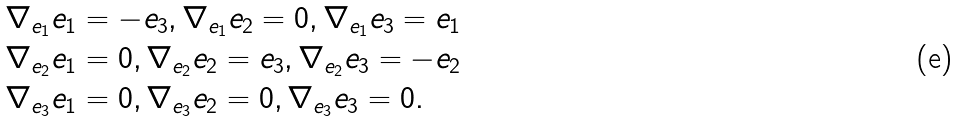<formula> <loc_0><loc_0><loc_500><loc_500>\begin{array} { l l l } \nabla _ { e _ { 1 } } e _ { 1 } = - e _ { 3 } , \nabla _ { e _ { 1 } } e _ { 2 } = 0 , \nabla _ { e _ { 1 } } e _ { 3 } = e _ { 1 } \\ \nabla _ { e _ { 2 } } e _ { 1 } = 0 , \nabla _ { e _ { 2 } } e _ { 2 } = e _ { 3 } , \nabla _ { e _ { 2 } } e _ { 3 } = - e _ { 2 } \\ \nabla _ { e _ { 3 } } e _ { 1 } = 0 , \nabla _ { e _ { 3 } } e _ { 2 } = 0 , \nabla _ { e _ { 3 } } e _ { 3 } = 0 . \\ \end{array}</formula> 